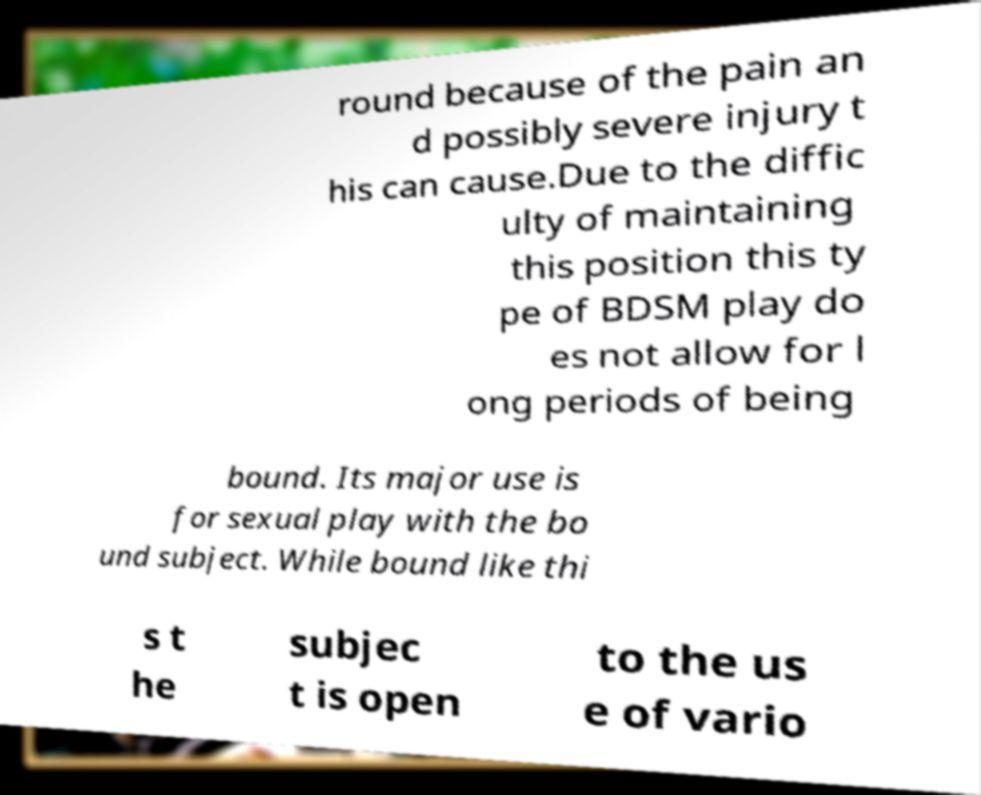What messages or text are displayed in this image? I need them in a readable, typed format. round because of the pain an d possibly severe injury t his can cause.Due to the diffic ulty of maintaining this position this ty pe of BDSM play do es not allow for l ong periods of being bound. Its major use is for sexual play with the bo und subject. While bound like thi s t he subjec t is open to the us e of vario 